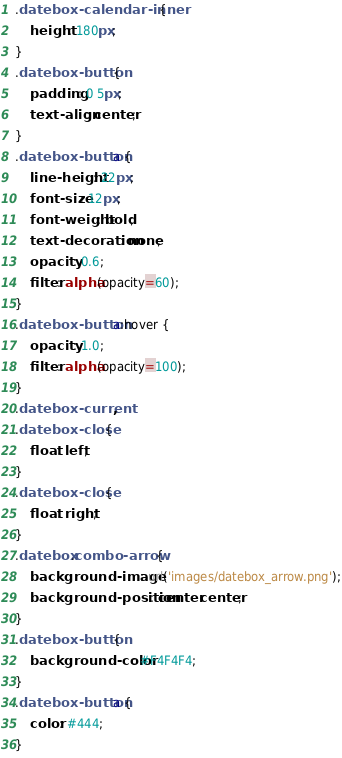<code> <loc_0><loc_0><loc_500><loc_500><_CSS_>.datebox-calendar-inner {
    height: 180px;
}
.datebox-button {
    padding: 0 5px;
    text-align: center;
}
.datebox-button a {
    line-height: 22px;
    font-size: 12px;
    font-weight: bold;
    text-decoration: none;
    opacity: 0.6;
    filter: alpha(opacity=60);
}
.datebox-button a:hover {
    opacity: 1.0;
    filter: alpha(opacity=100);
}
.datebox-current,
.datebox-close {
    float: left;
}
.datebox-close {
    float: right;
}
.datebox .combo-arrow {
    background-image: url('images/datebox_arrow.png');
    background-position: center center;
}
.datebox-button {
    background-color: #F4F4F4;
}
.datebox-button a {
    color: #444;
}
</code> 